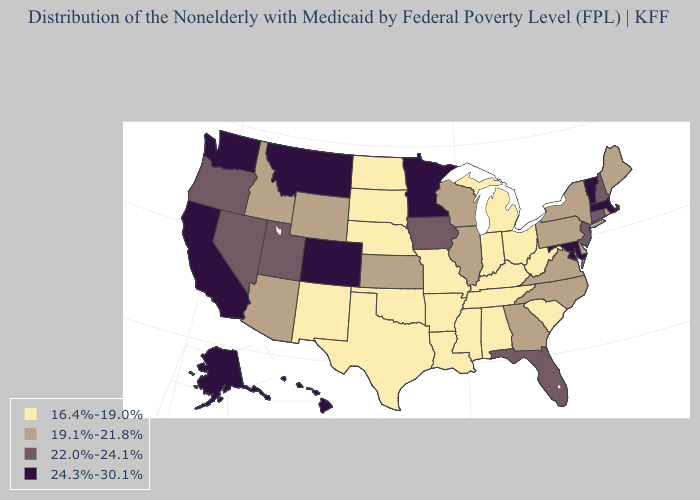Among the states that border Delaware , which have the lowest value?
Short answer required. Pennsylvania. Does Illinois have the lowest value in the USA?
Answer briefly. No. Which states have the lowest value in the USA?
Short answer required. Alabama, Arkansas, Indiana, Kentucky, Louisiana, Michigan, Mississippi, Missouri, Nebraska, New Mexico, North Dakota, Ohio, Oklahoma, South Carolina, South Dakota, Tennessee, Texas, West Virginia. Which states have the lowest value in the West?
Concise answer only. New Mexico. What is the highest value in the USA?
Write a very short answer. 24.3%-30.1%. What is the value of Kentucky?
Short answer required. 16.4%-19.0%. What is the lowest value in the West?
Be succinct. 16.4%-19.0%. What is the highest value in the West ?
Concise answer only. 24.3%-30.1%. Is the legend a continuous bar?
Give a very brief answer. No. Among the states that border Ohio , does West Virginia have the highest value?
Keep it brief. No. What is the value of Louisiana?
Be succinct. 16.4%-19.0%. What is the value of Delaware?
Short answer required. 19.1%-21.8%. What is the lowest value in the West?
Write a very short answer. 16.4%-19.0%. What is the value of Kansas?
Short answer required. 19.1%-21.8%. Name the states that have a value in the range 24.3%-30.1%?
Short answer required. Alaska, California, Colorado, Hawaii, Maryland, Massachusetts, Minnesota, Montana, Vermont, Washington. 